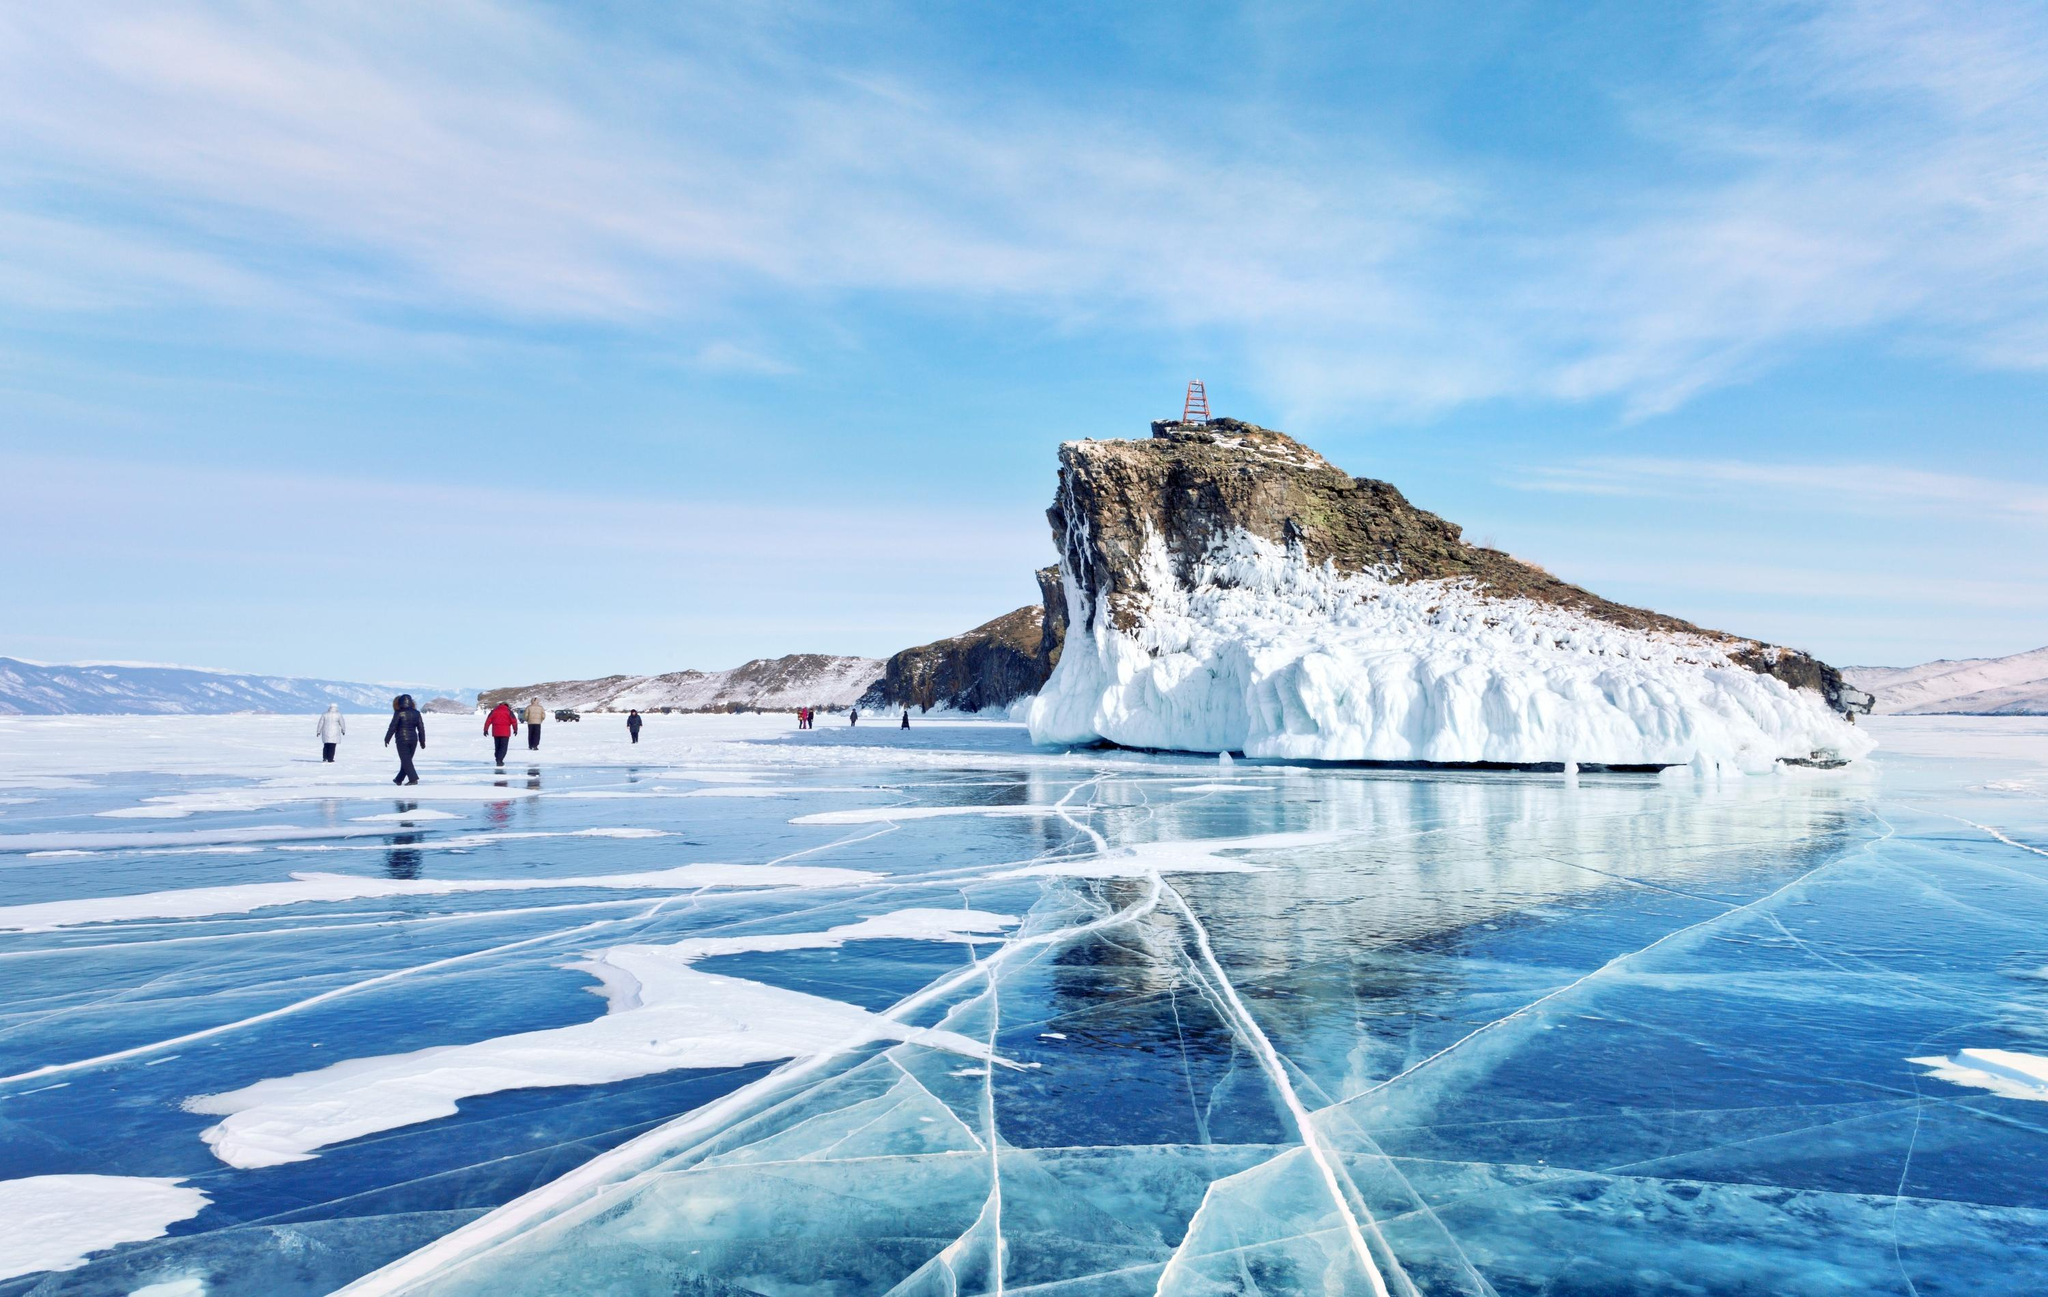How thick is the ice typically during this time of year at Lake Baikal, and what makes it safe for people to walk on? The ice on Lake Baikal can be up to two meters thick in the coldest months of winter. It becomes strong enough to support not just people but even heavier weights, thanks to the extreme temperatures that can drop below -20°C. The transparency of the ice, which can create an illusion of less thickness, is due to its purity and the lack of impurities in the water. Safety guidelines for walking on the ice include checking the thickness regularly, being aware of the weather conditions, and avoiding areas with visible flowing water or cracks. 